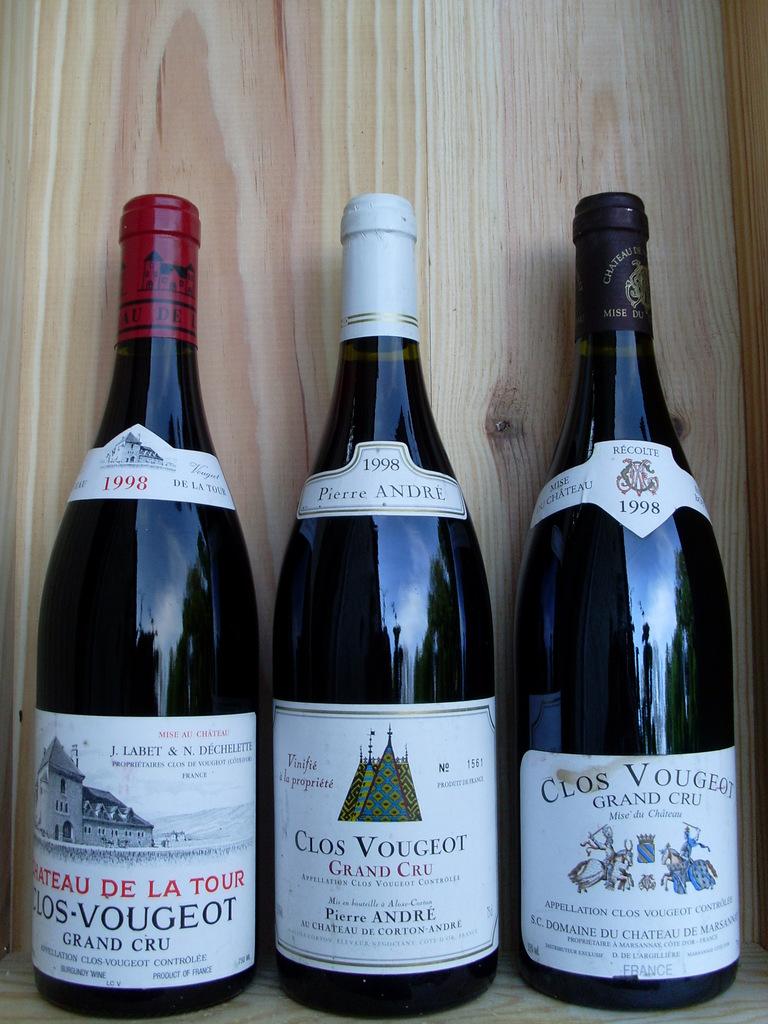What year were these bottled drinks made?
Ensure brevity in your answer.  1998. 